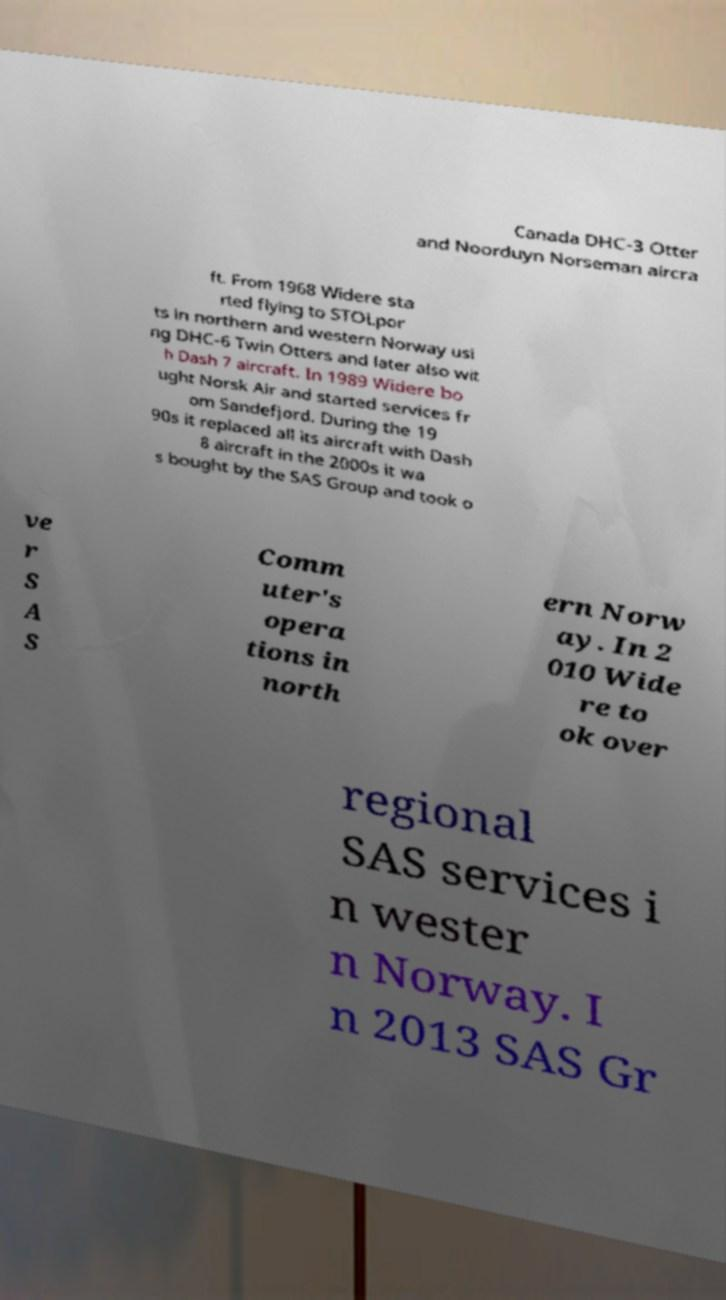Could you assist in decoding the text presented in this image and type it out clearly? Canada DHC-3 Otter and Noorduyn Norseman aircra ft. From 1968 Widere sta rted flying to STOLpor ts in northern and western Norway usi ng DHC-6 Twin Otters and later also wit h Dash 7 aircraft. In 1989 Widere bo ught Norsk Air and started services fr om Sandefjord. During the 19 90s it replaced all its aircraft with Dash 8 aircraft in the 2000s it wa s bought by the SAS Group and took o ve r S A S Comm uter's opera tions in north ern Norw ay. In 2 010 Wide re to ok over regional SAS services i n wester n Norway. I n 2013 SAS Gr 